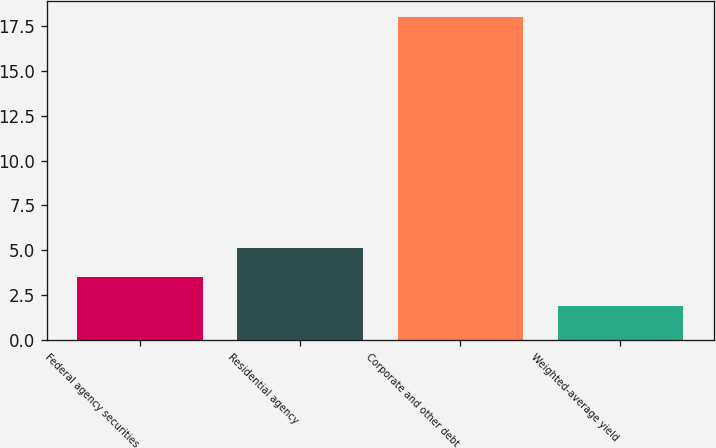<chart> <loc_0><loc_0><loc_500><loc_500><bar_chart><fcel>Federal agency securities<fcel>Residential agency<fcel>Corporate and other debt<fcel>Weighted-average yield<nl><fcel>3.51<fcel>5.12<fcel>18<fcel>1.9<nl></chart> 